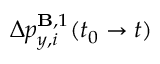<formula> <loc_0><loc_0><loc_500><loc_500>\Delta p _ { y , i } ^ { B , 1 } ( t _ { 0 } \to t )</formula> 